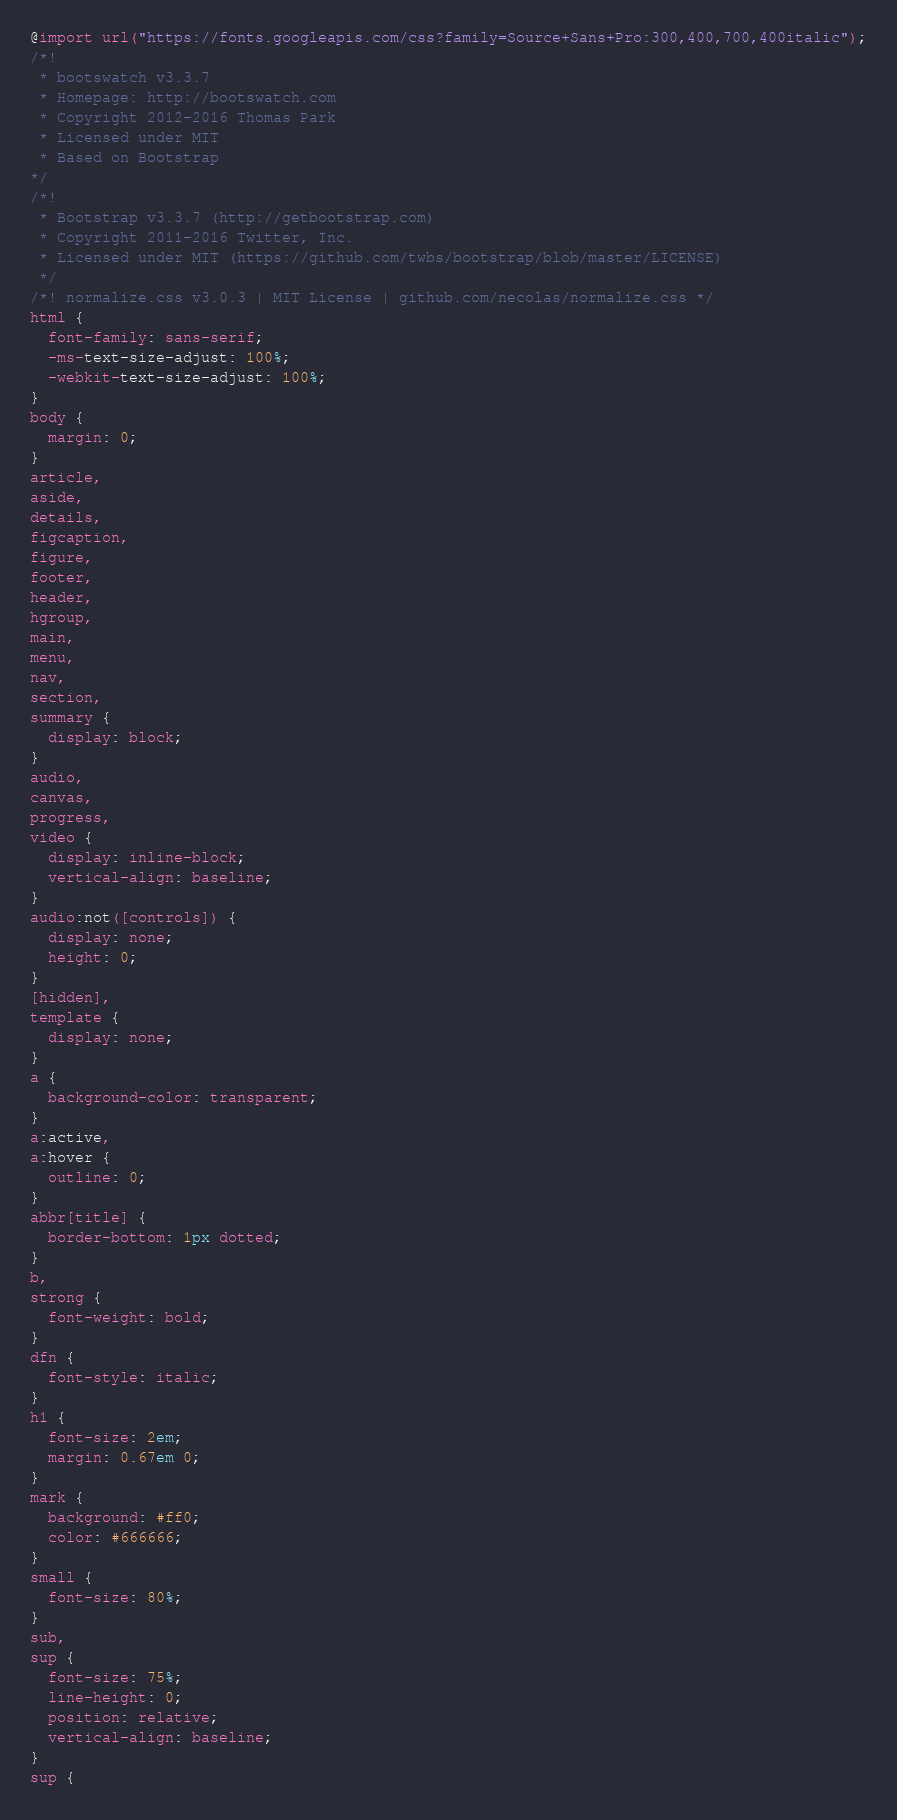Convert code to text. <code><loc_0><loc_0><loc_500><loc_500><_CSS_>@import url("https://fonts.googleapis.com/css?family=Source+Sans+Pro:300,400,700,400italic");
/*!
 * bootswatch v3.3.7
 * Homepage: http://bootswatch.com
 * Copyright 2012-2016 Thomas Park
 * Licensed under MIT
 * Based on Bootstrap
*/
/*!
 * Bootstrap v3.3.7 (http://getbootstrap.com)
 * Copyright 2011-2016 Twitter, Inc.
 * Licensed under MIT (https://github.com/twbs/bootstrap/blob/master/LICENSE)
 */
/*! normalize.css v3.0.3 | MIT License | github.com/necolas/normalize.css */
html {
  font-family: sans-serif;
  -ms-text-size-adjust: 100%;
  -webkit-text-size-adjust: 100%;
}
body {
  margin: 0;
}
article,
aside,
details,
figcaption,
figure,
footer,
header,
hgroup,
main,
menu,
nav,
section,
summary {
  display: block;
}
audio,
canvas,
progress,
video {
  display: inline-block;
  vertical-align: baseline;
}
audio:not([controls]) {
  display: none;
  height: 0;
}
[hidden],
template {
  display: none;
}
a {
  background-color: transparent;
}
a:active,
a:hover {
  outline: 0;
}
abbr[title] {
  border-bottom: 1px dotted;
}
b,
strong {
  font-weight: bold;
}
dfn {
  font-style: italic;
}
h1 {
  font-size: 2em;
  margin: 0.67em 0;
}
mark {
  background: #ff0;
  color: #666666;
}
small {
  font-size: 80%;
}
sub,
sup {
  font-size: 75%;
  line-height: 0;
  position: relative;
  vertical-align: baseline;
}
sup {</code> 